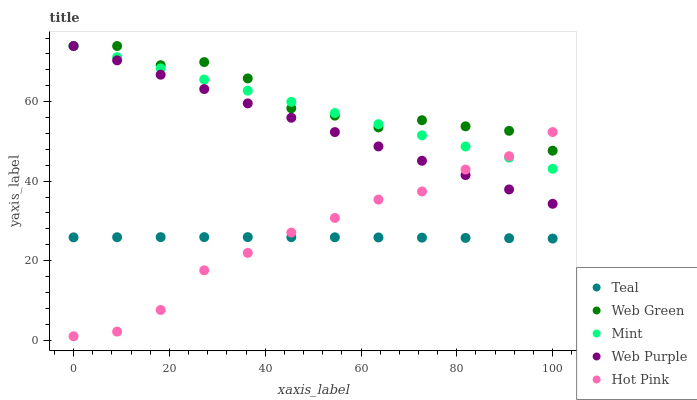Does Teal have the minimum area under the curve?
Answer yes or no. Yes. Does Web Green have the maximum area under the curve?
Answer yes or no. Yes. Does Hot Pink have the minimum area under the curve?
Answer yes or no. No. Does Hot Pink have the maximum area under the curve?
Answer yes or no. No. Is Web Purple the smoothest?
Answer yes or no. Yes. Is Web Green the roughest?
Answer yes or no. Yes. Is Hot Pink the smoothest?
Answer yes or no. No. Is Hot Pink the roughest?
Answer yes or no. No. Does Hot Pink have the lowest value?
Answer yes or no. Yes. Does Mint have the lowest value?
Answer yes or no. No. Does Web Green have the highest value?
Answer yes or no. Yes. Does Hot Pink have the highest value?
Answer yes or no. No. Is Teal less than Web Green?
Answer yes or no. Yes. Is Web Purple greater than Teal?
Answer yes or no. Yes. Does Web Purple intersect Mint?
Answer yes or no. Yes. Is Web Purple less than Mint?
Answer yes or no. No. Is Web Purple greater than Mint?
Answer yes or no. No. Does Teal intersect Web Green?
Answer yes or no. No. 